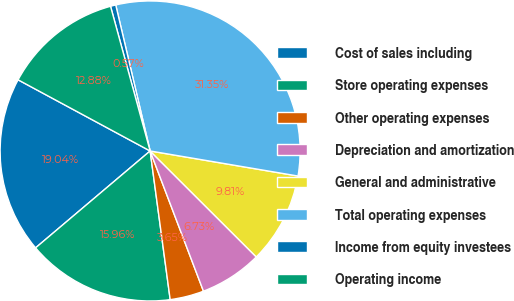Convert chart. <chart><loc_0><loc_0><loc_500><loc_500><pie_chart><fcel>Cost of sales including<fcel>Store operating expenses<fcel>Other operating expenses<fcel>Depreciation and amortization<fcel>General and administrative<fcel>Total operating expenses<fcel>Income from equity investees<fcel>Operating income<nl><fcel>19.04%<fcel>15.96%<fcel>3.65%<fcel>6.73%<fcel>9.81%<fcel>31.35%<fcel>0.57%<fcel>12.88%<nl></chart> 